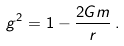Convert formula to latex. <formula><loc_0><loc_0><loc_500><loc_500>g ^ { 2 } = 1 - \frac { 2 G m } { r } \, .</formula> 